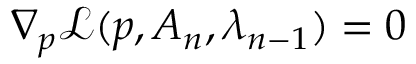<formula> <loc_0><loc_0><loc_500><loc_500>\nabla _ { p } \mathcal { L } ( p , A _ { n } , \lambda _ { n - 1 } ) = 0</formula> 